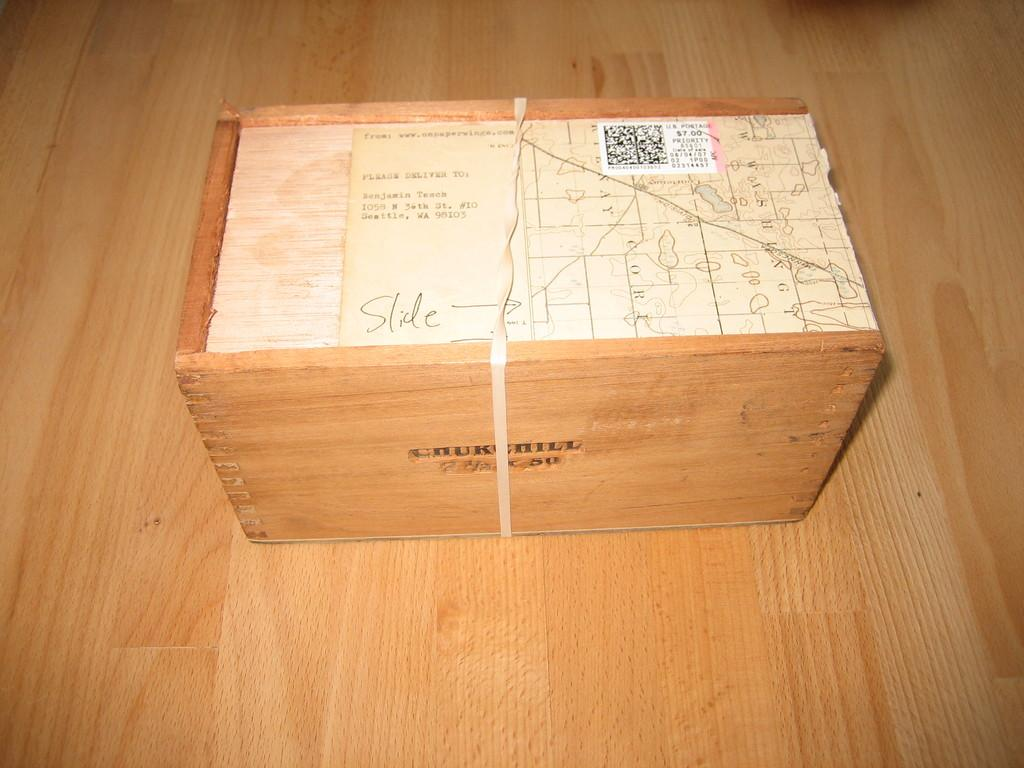<image>
Offer a succinct explanation of the picture presented. A wooden box addressed to Benjamin Teach placed on a floor. 